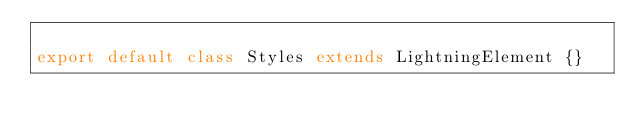<code> <loc_0><loc_0><loc_500><loc_500><_JavaScript_>
export default class Styles extends LightningElement {}</code> 